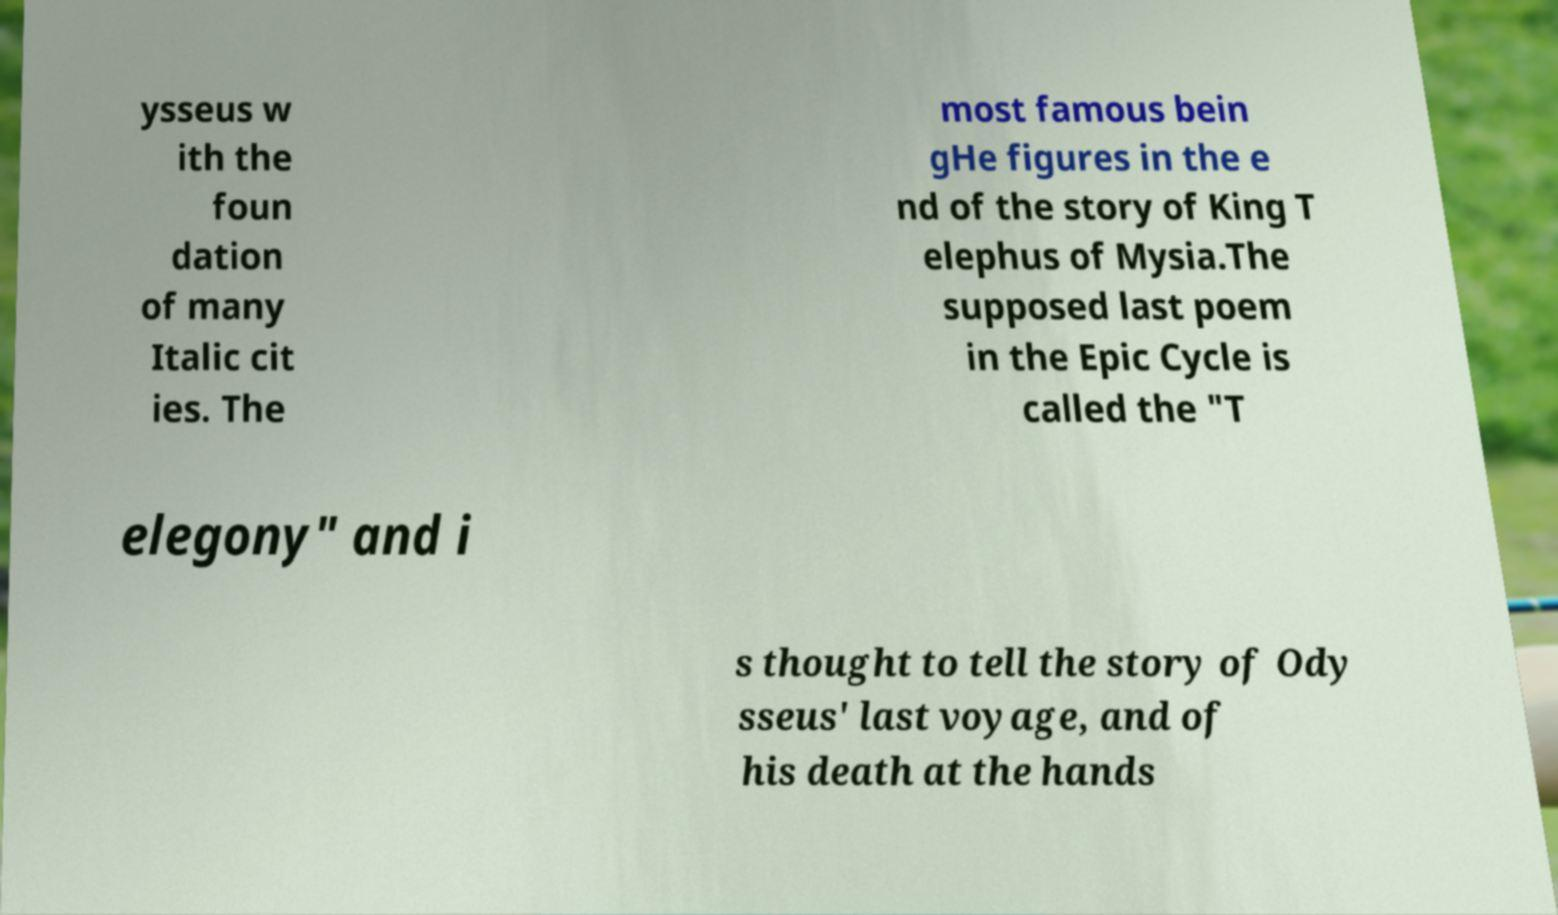I need the written content from this picture converted into text. Can you do that? ysseus w ith the foun dation of many Italic cit ies. The most famous bein gHe figures in the e nd of the story of King T elephus of Mysia.The supposed last poem in the Epic Cycle is called the "T elegony" and i s thought to tell the story of Ody sseus' last voyage, and of his death at the hands 